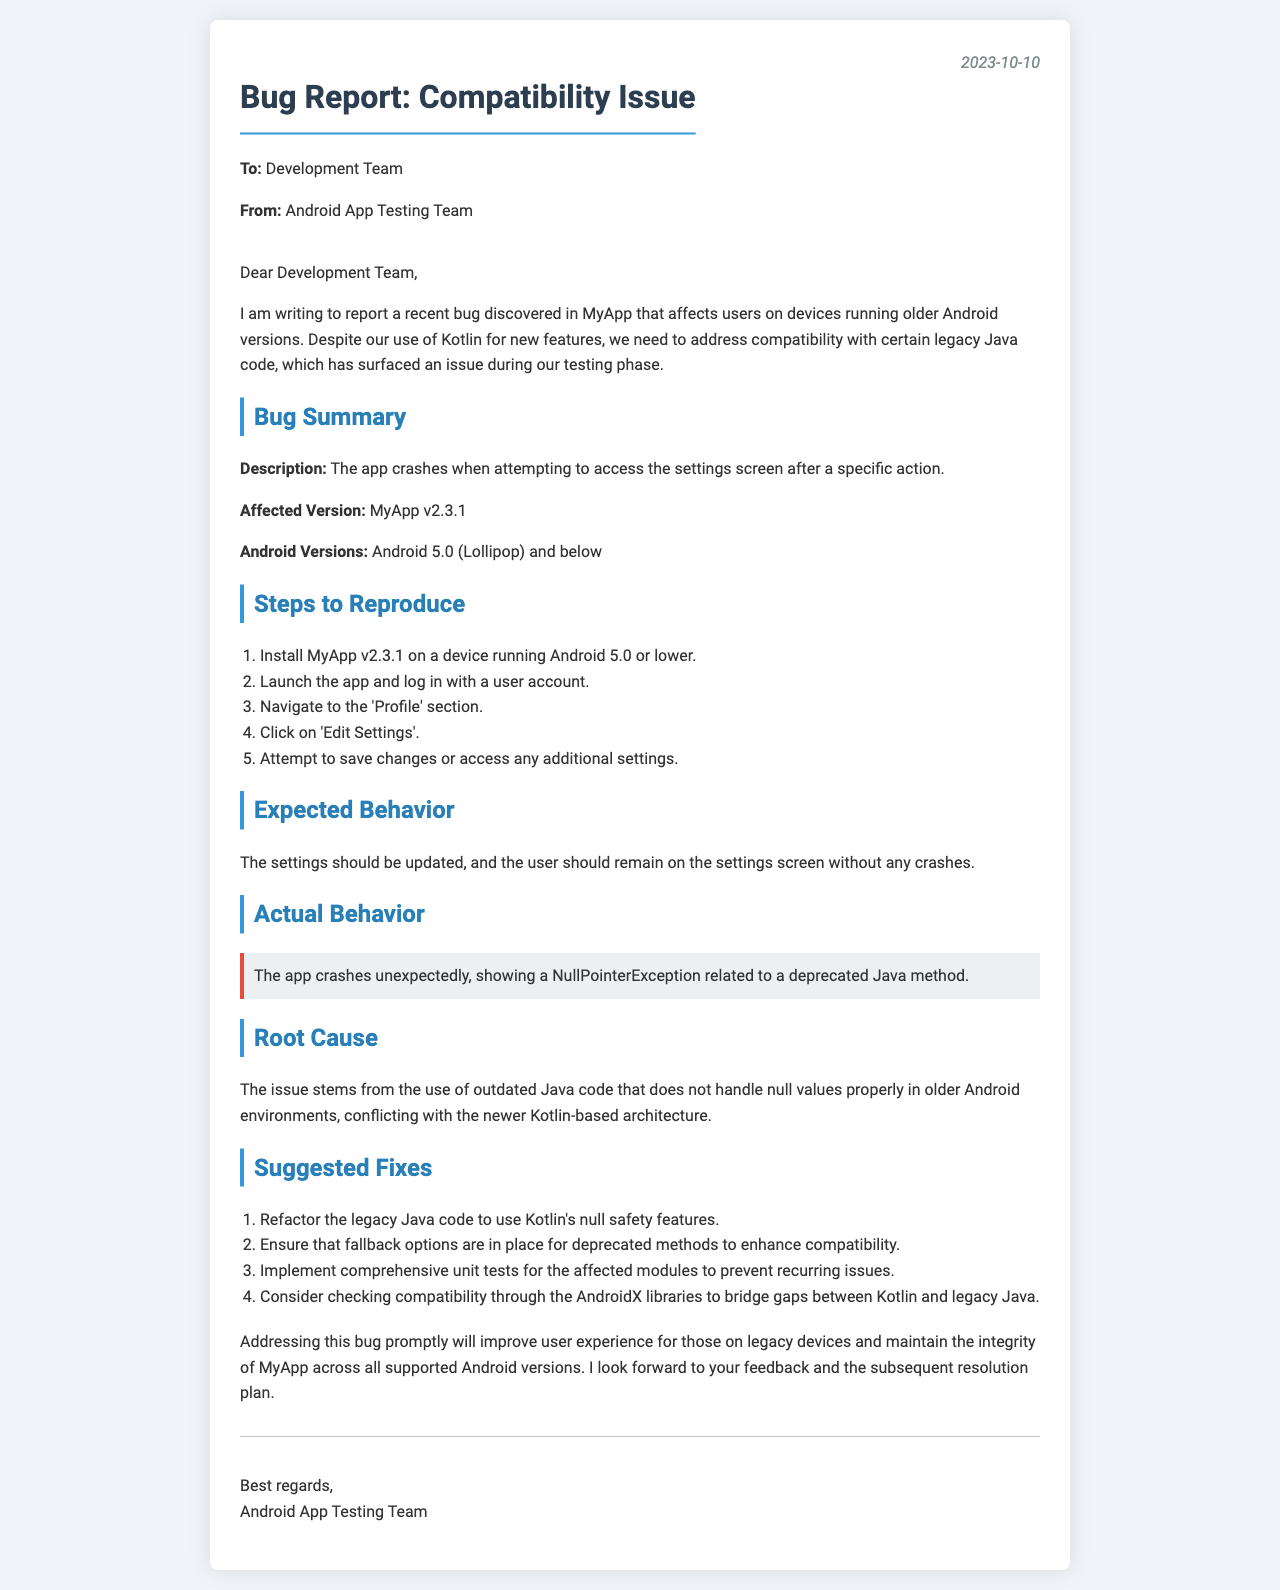what is the app version affected by the bug? The affected version of the app is explicitly mentioned in the document under "Affected Version."
Answer: MyApp v2.3.1 what is the date of the bug report? The date of the bug report is provided in the header section.
Answer: 2023-10-10 which Android versions are impacted by the bug? The impacted Android versions are listed under "Android Versions."
Answer: Android 5.0 (Lollipop) and below what is the expected behavior mentioned in the document? The expected behavior is described under the "Expected Behavior" section of the document.
Answer: The settings should be updated without any crashes what type of exception is causing the app to crash? The exception causing the crash is specifically stated in the "Actual Behavior" section.
Answer: NullPointerException what is suggested as the first fix to address the bug? The first suggested fix can be found in the "Suggested Fixes" section.
Answer: Refactor the legacy Java code to use Kotlin's null safety features what is the root cause of the issue? The root cause is summarized in the "Root Cause" section of the letter.
Answer: Outdated Java code not handling null values properly who is the letter addressed to? The recipient of the letter is mentioned at the start of the document.
Answer: Development Team 